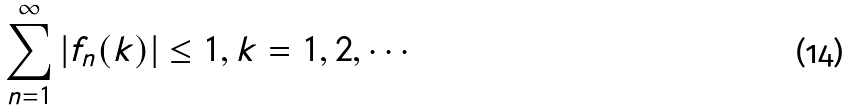<formula> <loc_0><loc_0><loc_500><loc_500>\sum _ { n = 1 } ^ { \infty } | f _ { n } ( k ) | \leq 1 , k = 1 , 2 , \cdots</formula> 